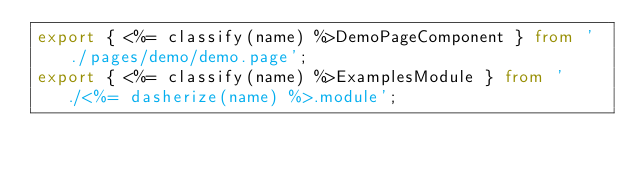Convert code to text. <code><loc_0><loc_0><loc_500><loc_500><_TypeScript_>export { <%= classify(name) %>DemoPageComponent } from './pages/demo/demo.page';
export { <%= classify(name) %>ExamplesModule } from './<%= dasherize(name) %>.module';
</code> 